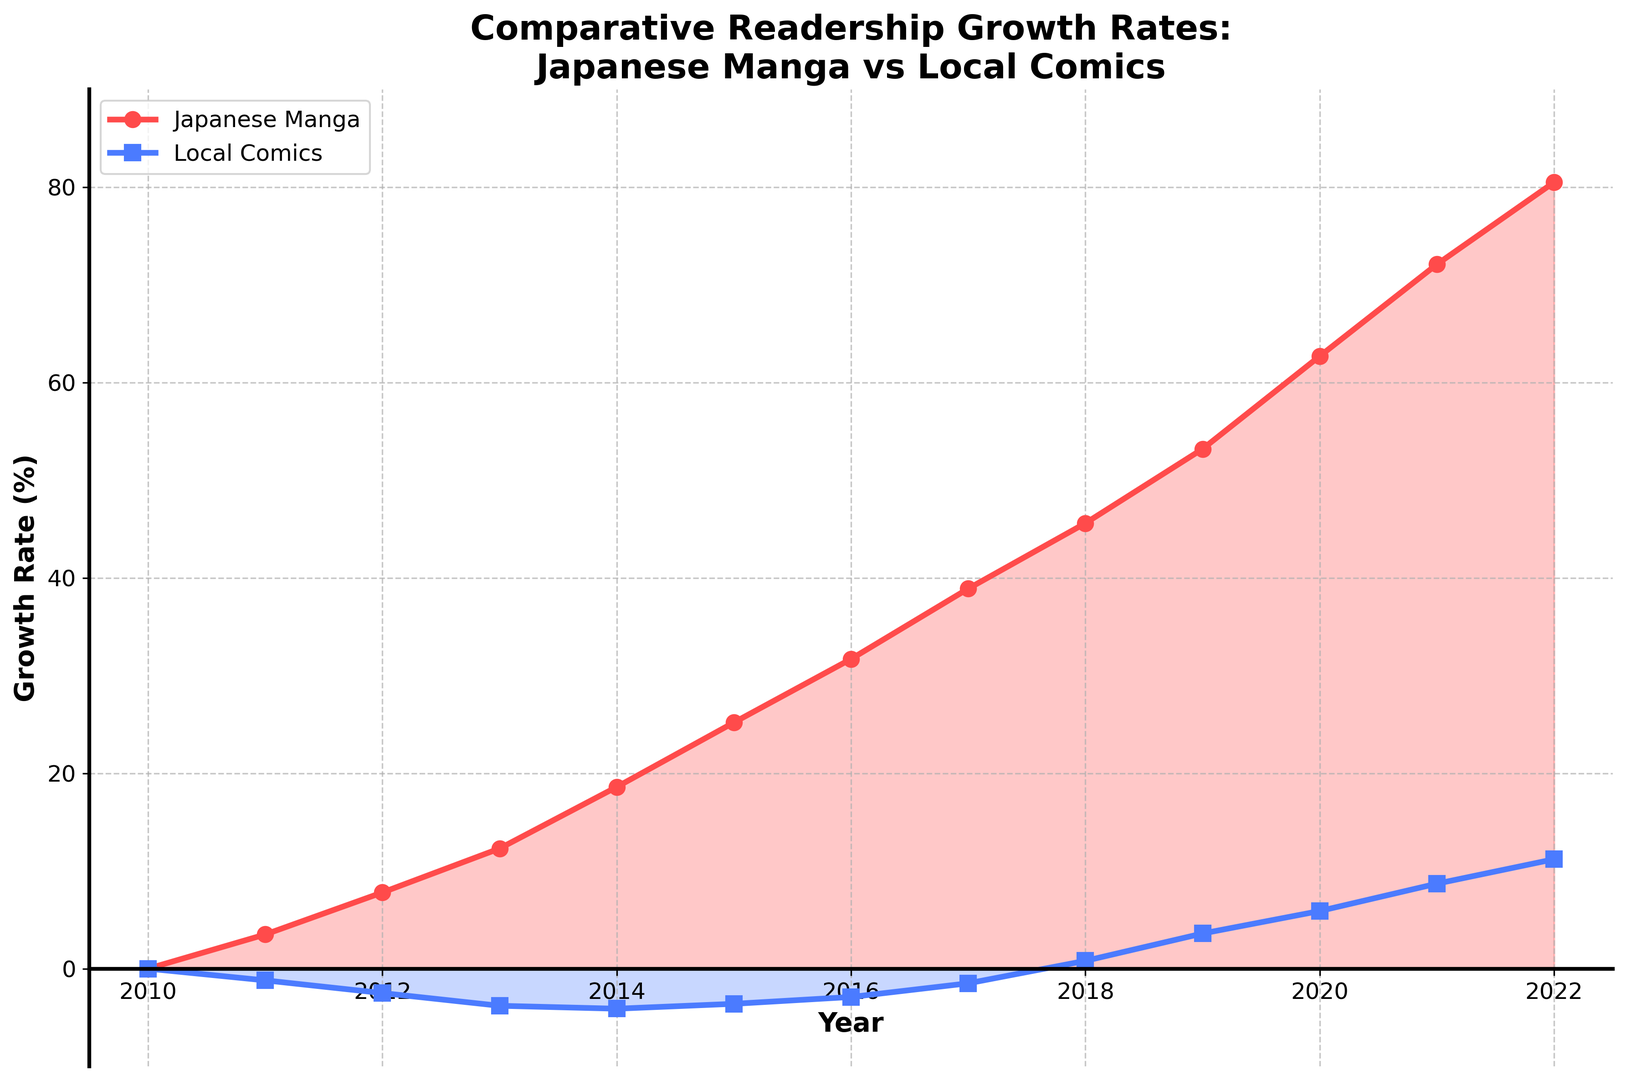What was the growth rate of Japanese manga in the year 2020? To find the growth rate of Japanese manga in 2020, we look at the value marked for the year 2020 on the line representing Japanese manga. The value is 62.7%.
Answer: 62.7% Which type of comics had a negative growth rate in 2015? Observing the graph for the year 2015, note which lines are below the horizontal axis. The line for Local Comics is below, indicating a negative growth rate.
Answer: Local Comics What is the difference in the growth rates of Japanese manga and local comics in 2014? Look at the data points for the year 2014 for both Japanese manga and local comics. Japanese manga has a growth rate of 18.6%, and local comics have -4.1%. The difference is 18.6% - (-4.1%) = 22.7%.
Answer: 22.7% In which year did Local Comics experience positive growth for the first time? Observing the line representing Local Comics, find the first instance where it crosses above the horizontal axis indicating a positive growth rate. This occurs in the year 2018.
Answer: 2018 Compare the growth rates of Japanese manga in 2011 and 2019. Which year had a higher growth rate and by how much? Looking at the values for Japanese manga in 2011 and 2019, the growth rates are 3.5% and 53.2% respectively. To find the difference, subtract the smaller value from the larger one: 53.2% - 3.5% = 49.7%. Thus, 2019 had a higher growth rate by 49.7%.
Answer: 2019 by 49.7% What is the trend observed in the growth rates of local comics from 2010 to 2022? Observing the graph from 2010 to 2022 for Local Comics, the growth rate starts negative, gradually becomes less negative, turns positive in 2018, and continues to rise after that. This indicates an overall upward trend.
Answer: Upward trend Between which consecutive years did Japanese manga see the largest increase in growth rate? To find the largest increase, calculate the differences between each consecutive year's growth rate for Japanese manga. The largest difference is between 2021 (72.1%) and 2022 (80.5%), which is 80.5% - 72.1% = 8.4%.
Answer: 2021 and 2022 What visually distinguishes the growth of Japanese manga compared to local comics in the plot? Visually, Japanese manga is represented by a red line and shows a steady upward trend, consistently above the horizontal axis. Local comics are represented by a blue line, starting below the axis and turning positive only after 2018. The red area indicates positive growth for Japanese manga, and the blue area indicates negative growth for local comics until 2018.
Answer: Red line and steady growth for Japanese manga, blue line with initial negative growth for local comics 